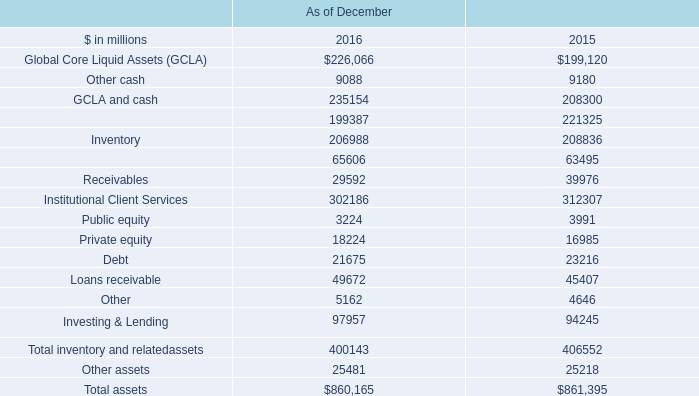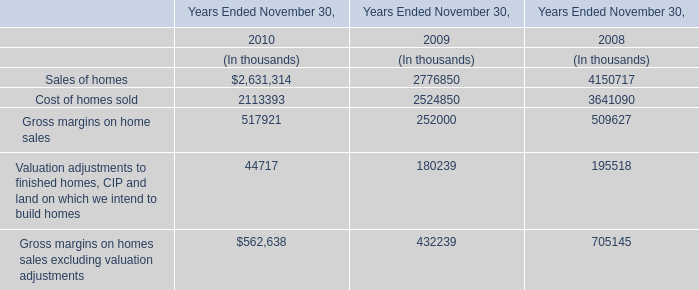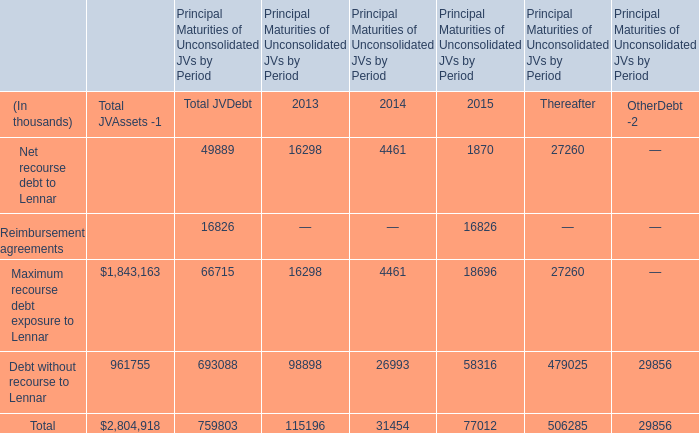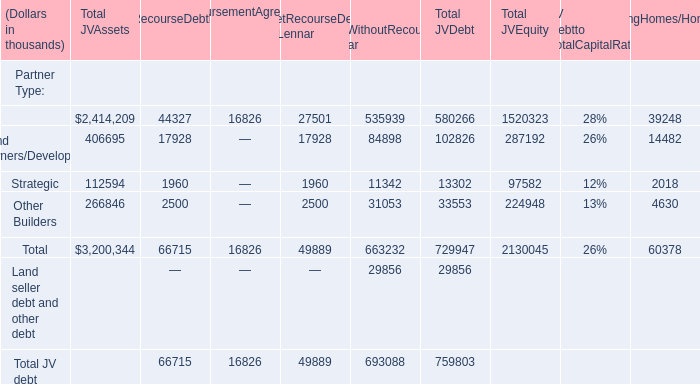What do all Total JV Assets sum up, excluding those negative ones? (in thousand) 
Computations: (1843163 + 961755)
Answer: 2804918.0. 